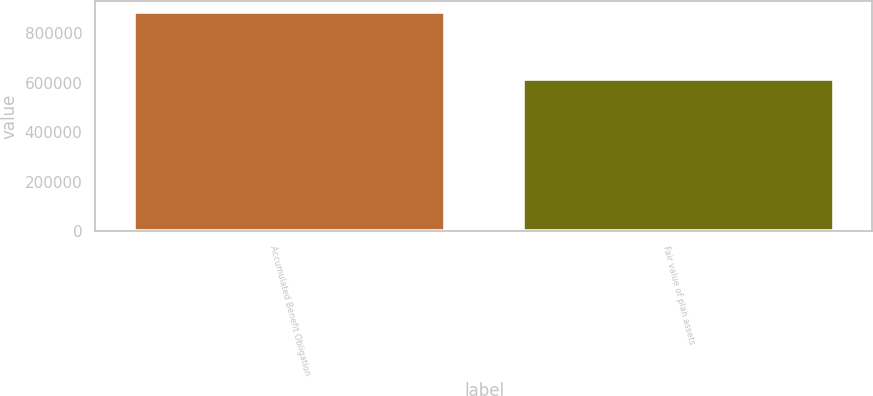Convert chart to OTSL. <chart><loc_0><loc_0><loc_500><loc_500><bar_chart><fcel>Accumulated Benefit Obligation<fcel>Fair value of plan assets<nl><fcel>885531<fcel>615563<nl></chart> 